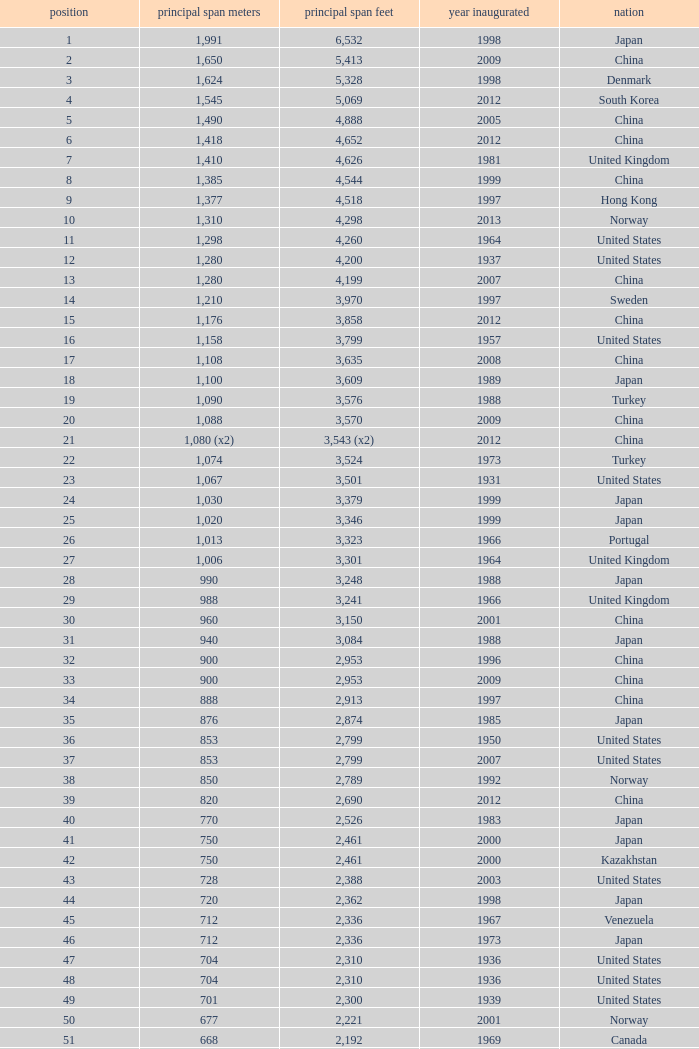What is the highest rank from the year greater than 2010 with 430 main span metres? 94.0. 